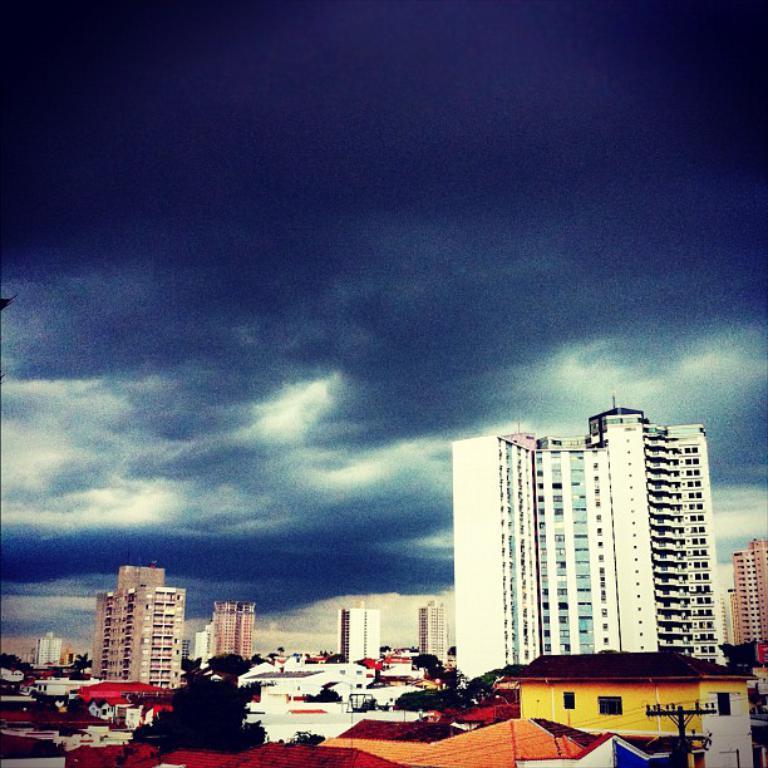What type of structures can be seen in the image? There are buildings and houses in the image. What other natural elements are present in the image? There are trees in the image. What utility infrastructure is visible in the image? There is an electric pole with cables in the image. How would you describe the weather in the image? The sky is cloudy in the image. Are there any giants visible in the image? No, there are no giants present in the image. What type of airport can be seen in the image? There is no airport visible in the image. 